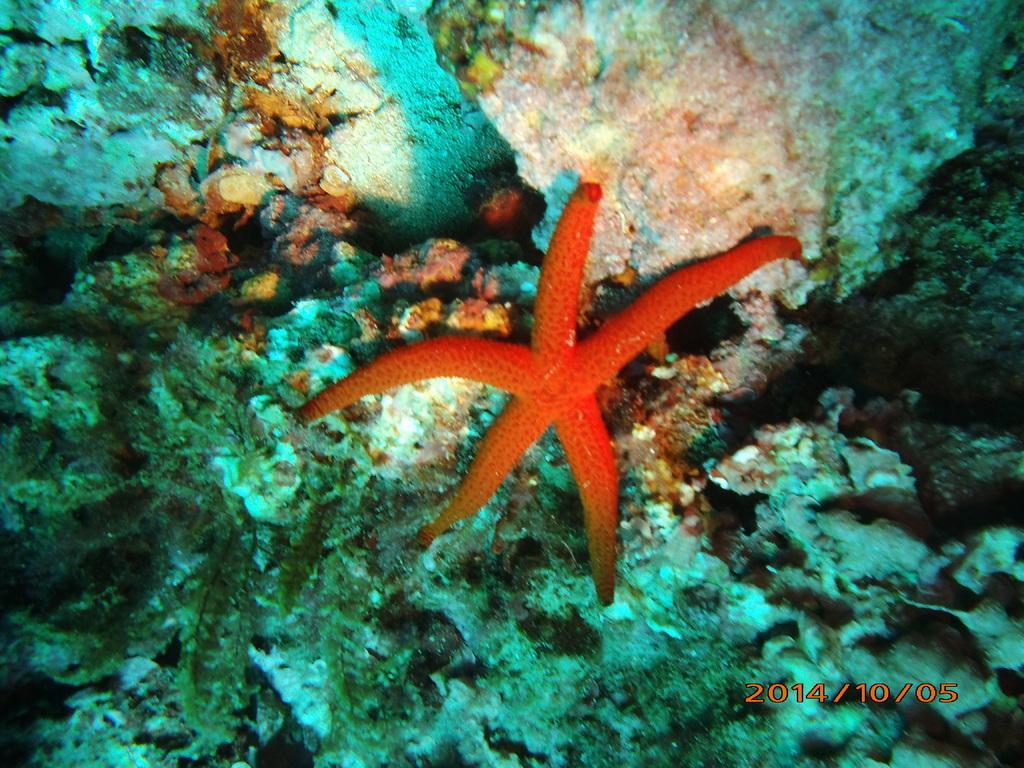Could you give a brief overview of what you see in this image? In the image we can see a starfish. Behind the starfish we can see underwater environment. 